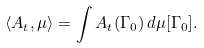Convert formula to latex. <formula><loc_0><loc_0><loc_500><loc_500>\langle A _ { t } , \mu \rangle = \int A _ { t } ( \Gamma _ { 0 } ) \, d \mu [ \Gamma _ { 0 } ] .</formula> 